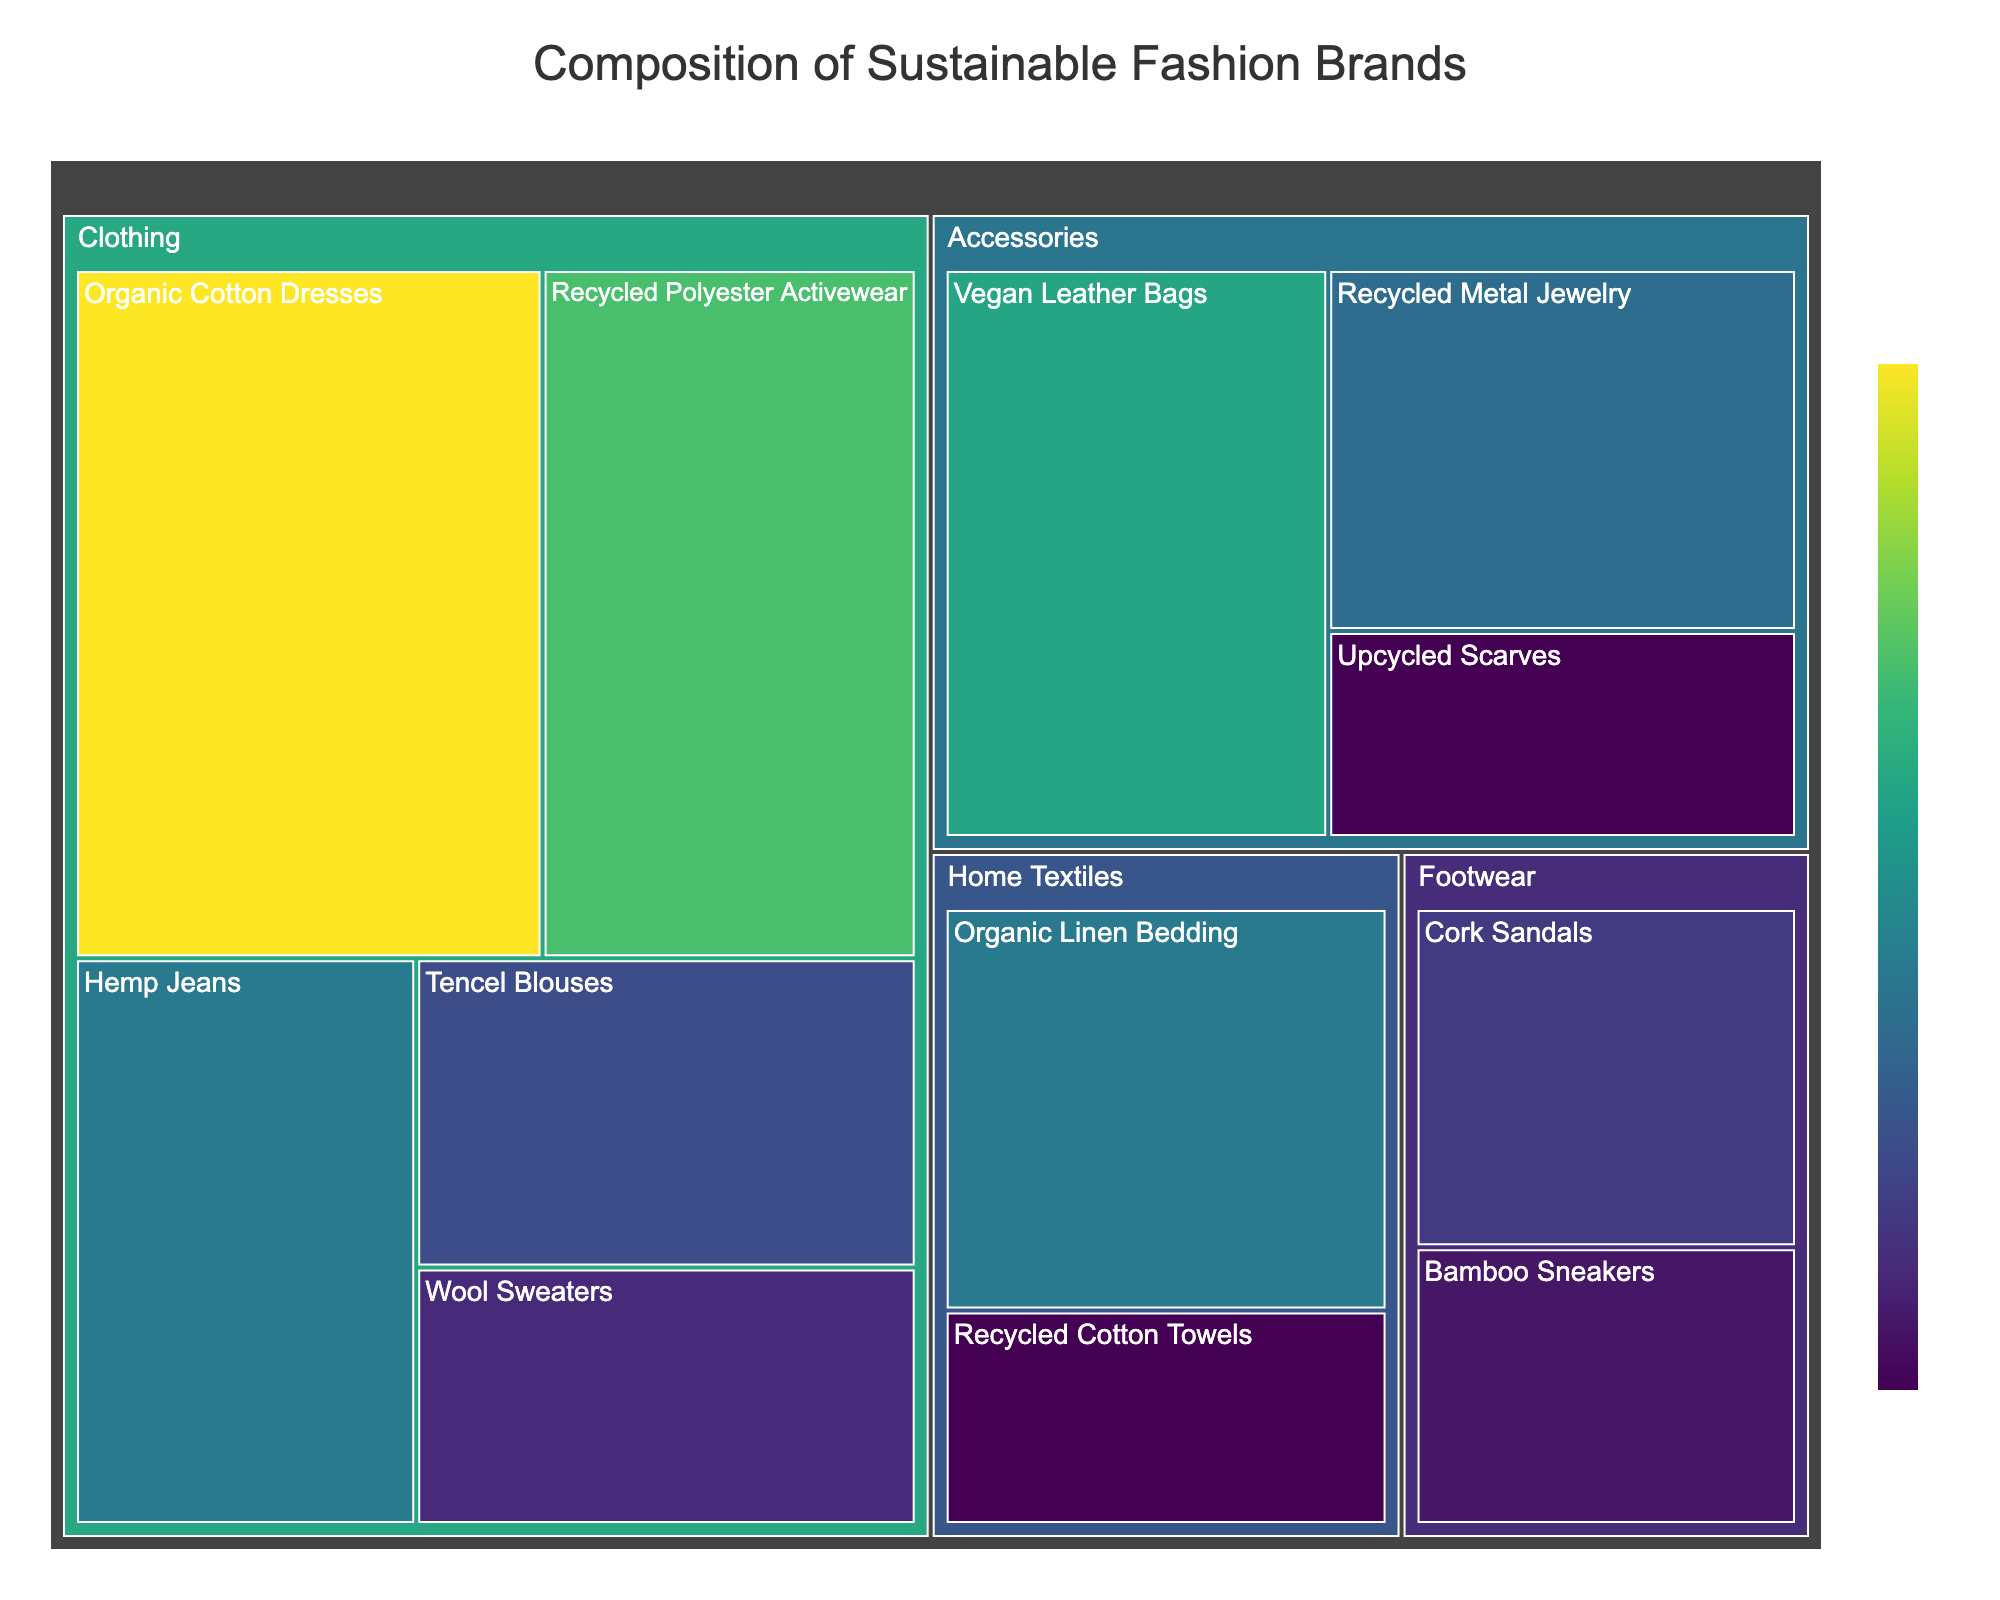what is the total number of value for Clothing category? Add up the values of the subcategories under Clothing: Organic Cotton Dresses (25), Recycled Polyester Activewear (20), Hemp Jeans (15), Tencel Blouses (12), Wool Sweaters (10). Therefore, the total value is 25 + 20 + 15 + 12 + 10 = 82
Answer: 82 which subcategory in Clothing has the highest value? Within the Clothing category, compare the values of the subcategories: Organic Cotton Dresses (25), Recycled Polyester Activewear (20), Hemp Jeans (15), Tencel Blouses (12), Wool Sweaters (10). The highest value among them is Organic Cotton Dresses with a value of 25
Answer: Organic Cotton Dresses How does the value of Vegan Leather Bags compare to Recycled Metal Jewelry? Compare the values of Vegan Leather Bags (18) and Recycled Metal Jewelry (14) in the Accessories category: 18 is greater than 14
Answer: Vegan Leather Bags has a higher value than Recycled Metal Jewelry What is the combined value of items in the Accessories category? Add up the values of the subcategories under Accessories: Vegan Leather Bags (18), Recycled Metal Jewelry (14), Upcycled Scarves (8). Therefore, the combined value is 18 + 14 + 8 = 40
Answer: 40 Which category has more diversity in subcategories, Clothing or Footwear? Count the number of subcategories in each category: Clothing has five subcategories (Organic Cotton Dresses, Recycled Polyester Activewear, Hemp Jeans, Tencel Blouses, Wool Sweaters), while Footwear has two subcategories (Cork Sandals, Bamboo Sneakers). So, Clothing has more diversity
Answer: Clothing What’s the smallest value represented in the Treemap? Look for the smallest value across all subcategories. The values are 25, 20, 15, 12, 10, 18, 14, 8, 11, 9, 15, and 8. The smallest value among these is 8
Answer: 8 what is the difference in value between Organic Cotton Dresses and Recycled Cotton Towels? Subtract the value of Recycled Cotton Towels (8) from the value of Organic Cotton Dresses (25): 25 - 8 = 17
Answer: 17 Which subcategory within Footwear has a larger value? Compare the values of the subcategories under Footwear: Cork Sandals (11) and Bamboo Sneakers (9). Cork Sandals has a larger value with 11 compared to Bamboo Sneakers with 9
Answer: Cork Sandals Which subcategory has the closest value to Organic Linen Bedding? Check the values next to the 15 value of Organic Linen Bedding. The other subcategory with a value of 15 is Hemp Jeans
Answer: Hemp Jeans What is the total value of Home Textiles category? Add up the values of the subcategories under Home Textiles: Organic Linen Bedding (15), Recycled Cotton Towels (8). Therefore, the total value is 15 + 8 = 23
Answer: 23 